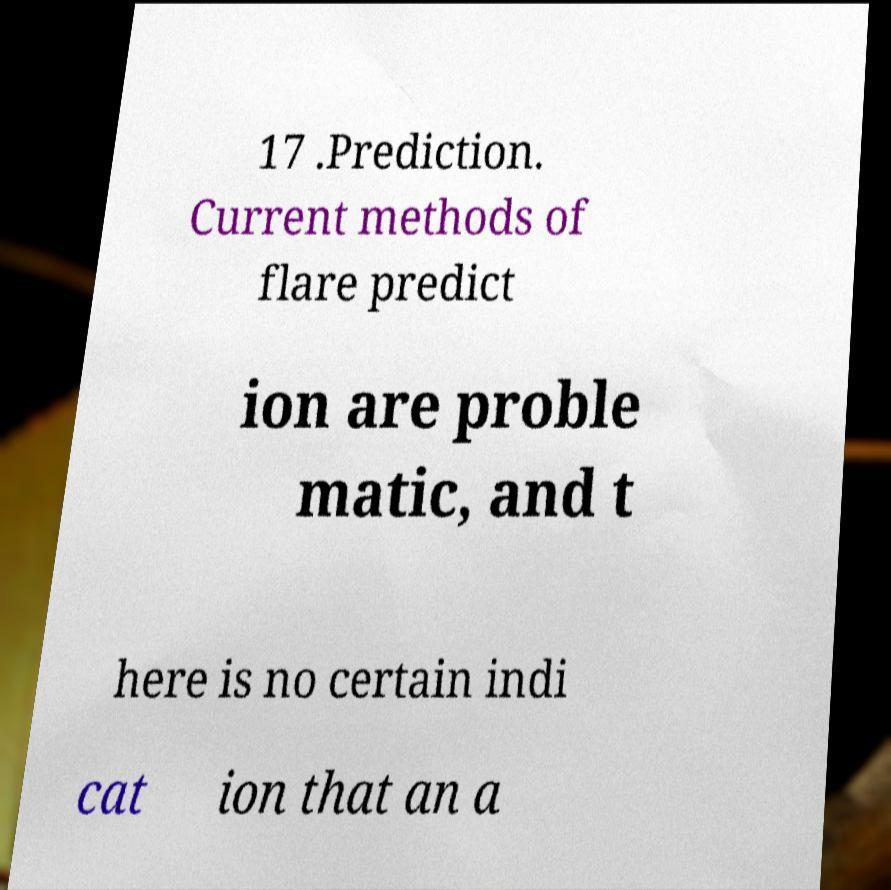For documentation purposes, I need the text within this image transcribed. Could you provide that? 17 .Prediction. Current methods of flare predict ion are proble matic, and t here is no certain indi cat ion that an a 